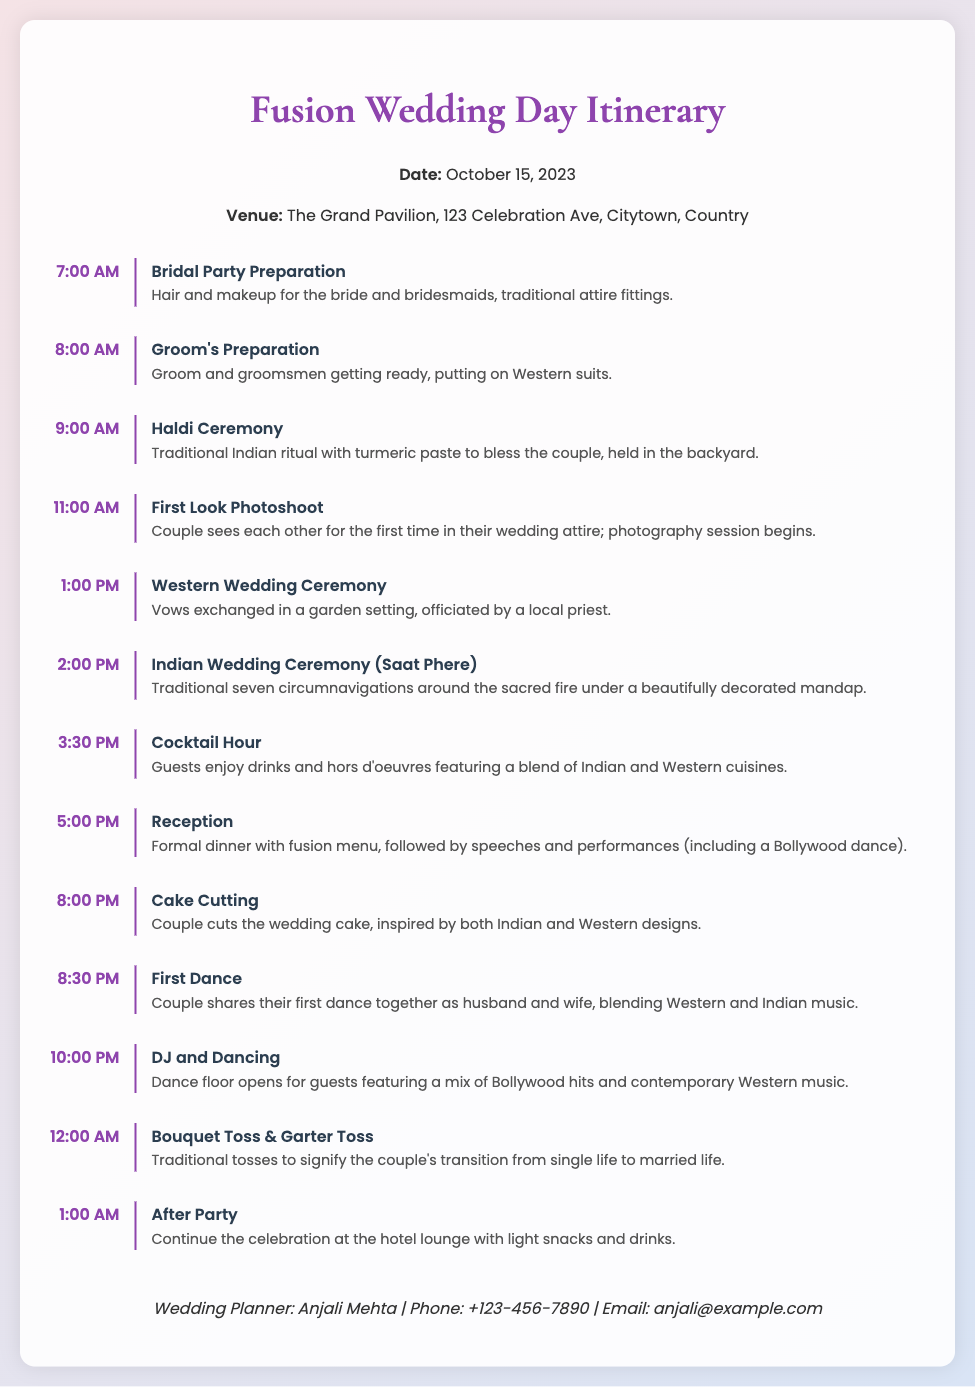What time does the Bridal Party Preparation start? The schedule indicates that the Bridal Party Preparation starts at 7:00 AM.
Answer: 7:00 AM What is the venue for the wedding? The document states the venue is The Grand Pavilion, 123 Celebration Ave, Citytown, Country.
Answer: The Grand Pavilion, 123 Celebration Ave, Citytown, Country What is the first event of the day? According to the itinerary, the first event of the day is the Bridal Party Preparation.
Answer: Bridal Party Preparation How long is the cocktail hour? The cocktail hour starts at 3:30 PM and ends at 5:00 PM, lasting for 1.5 hours.
Answer: 1.5 hours What unique feature is included in the Reception? The Reception includes speeches and performances, including a Bollywood dance.
Answer: Bollywood dance How many circumnavigations are performed in the Indian Wedding Ceremony? The Indian Wedding Ceremony involves seven circumnavigations around the sacred fire, known as Saat Phere.
Answer: Seven What symbolizes the couple's transition from single life? The Bouquet Toss and Garter Toss symbolize the couple's transition from single life to married life.
Answer: Bouquet Toss & Garter Toss What type of music will be played during the first dance? The first dance will blend Western and Indian music.
Answer: Western and Indian music What is the final event listed in the itinerary? The final event listed in the itinerary is the After Party at the hotel lounge.
Answer: After Party 